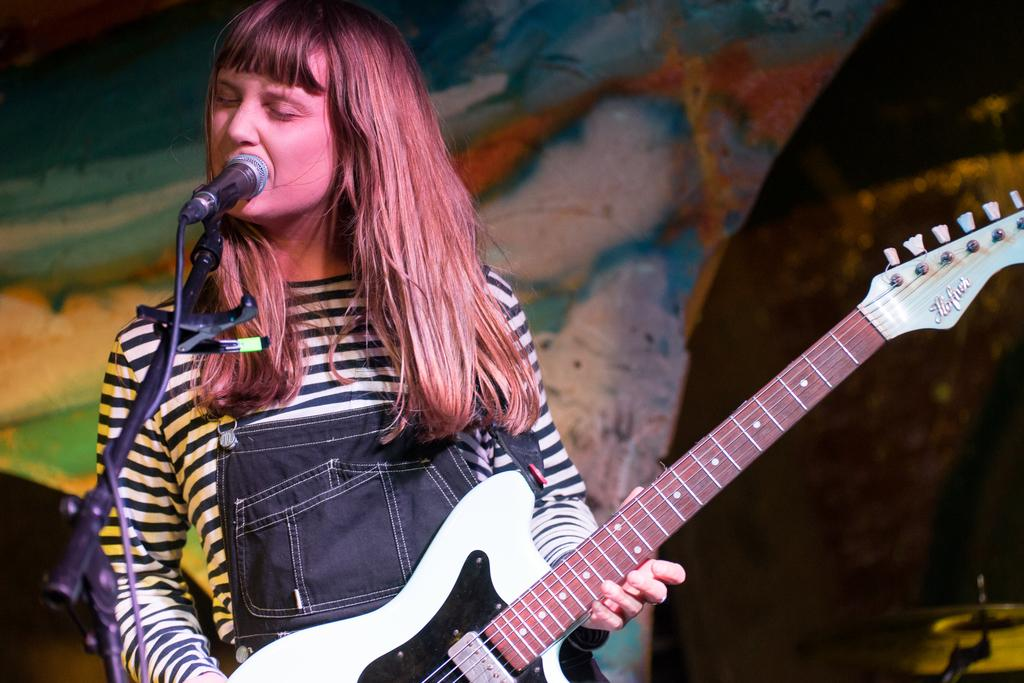What is the girl in the image doing? The girl is singing a song in the image. What is she using to amplify her voice? She is using a microphone in the image. Is there any equipment to support the microphone? Yes, there is a microphone stand in the image. What instrument is the girl playing? The girl is playing a guitar in the image. Can you describe the girl's outfit? She is wearing a jumpsuit dress in the image. What is a noticeable feature of the girl's appearance? The girl has very long hair in the image. What arithmetic problem is the girl solving on the street in the image? There is no arithmetic problem or street present in the image. What type of cup is the girl holding while playing the guitar? There is no cup present in the image. 